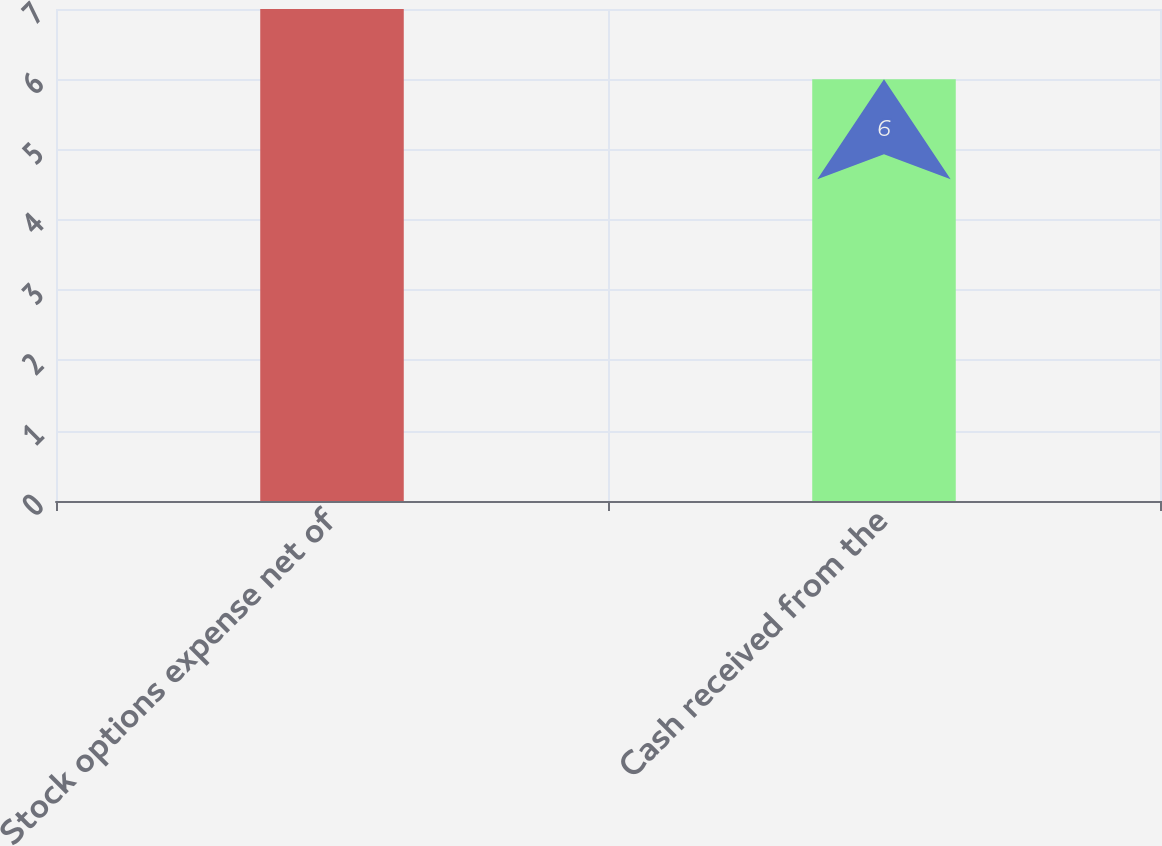Convert chart to OTSL. <chart><loc_0><loc_0><loc_500><loc_500><bar_chart><fcel>Stock options expense net of<fcel>Cash received from the<nl><fcel>7<fcel>6<nl></chart> 